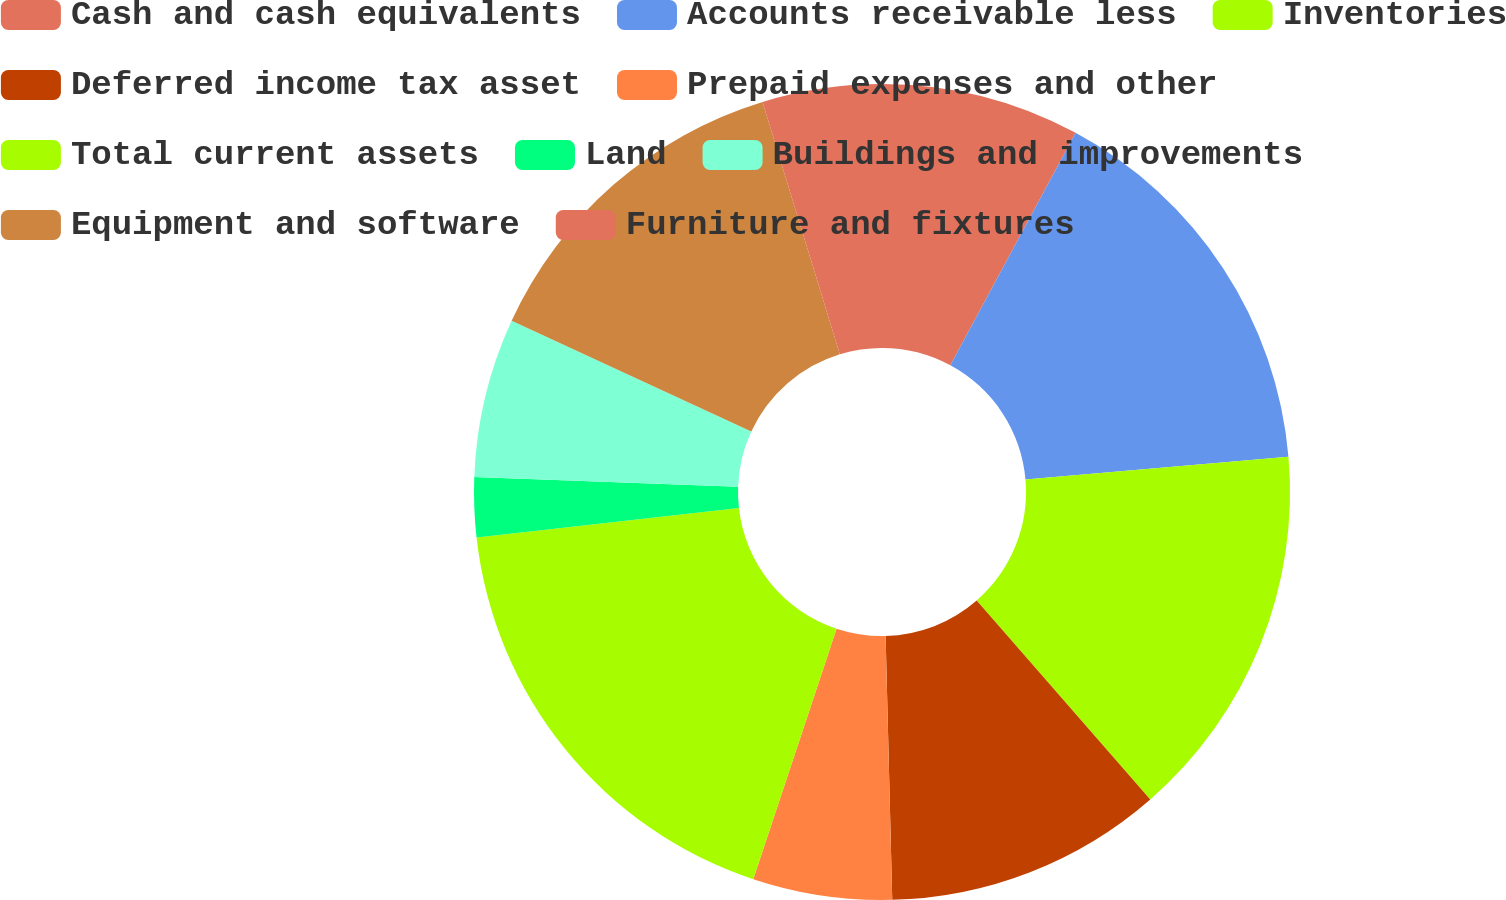Convert chart to OTSL. <chart><loc_0><loc_0><loc_500><loc_500><pie_chart><fcel>Cash and cash equivalents<fcel>Accounts receivable less<fcel>Inventories<fcel>Deferred income tax asset<fcel>Prepaid expenses and other<fcel>Total current assets<fcel>Land<fcel>Buildings and improvements<fcel>Equipment and software<fcel>Furniture and fixtures<nl><fcel>7.87%<fcel>15.75%<fcel>14.96%<fcel>11.02%<fcel>5.51%<fcel>18.11%<fcel>2.37%<fcel>6.3%<fcel>13.38%<fcel>4.73%<nl></chart> 